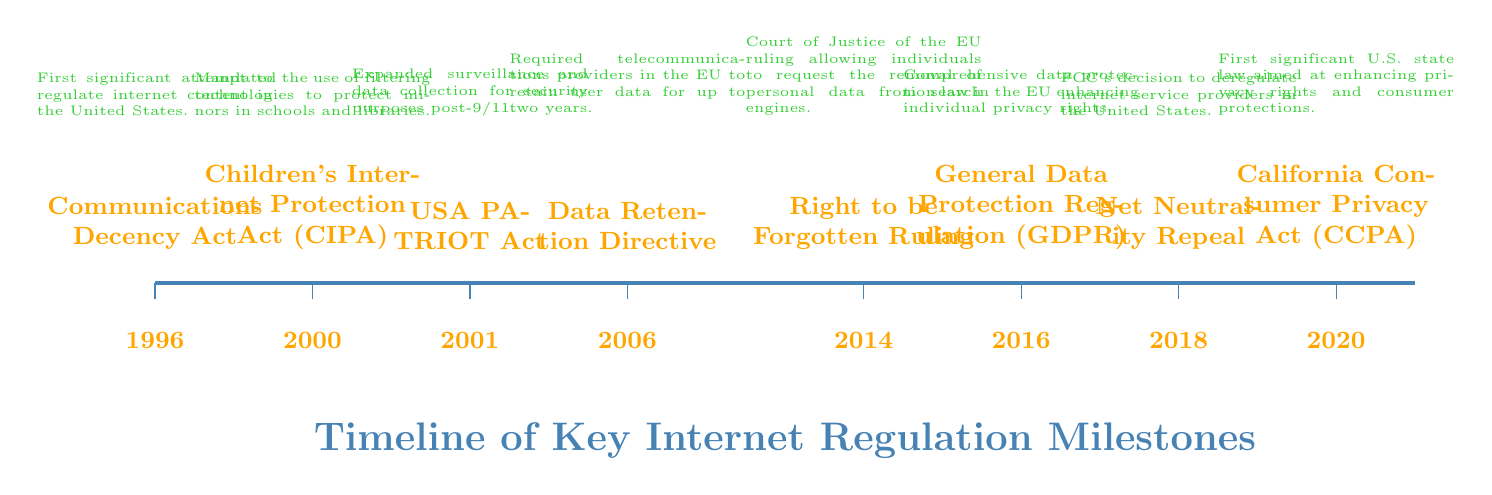What year was the Communications Decency Act enacted? The diagram indicates that the Communications Decency Act was enacted in the year 1996, as stated directly above the related event marker.
Answer: 1996 How many key milestones are represented in the timeline? By counting the events listed in the diagram from 1996 to 2020, there are a total of eight key milestones shown along the timeline.
Answer: 8 What event occurred in 2016? The event corresponding to 2016 in the timeline is labeled "Net Neutrality Repeal," which is clearly indicated above the year marker in the diagram.
Answer: Net Neutrality Repeal What was the main purpose of the General Data Protection Regulation (GDPR)? The description associated with the GDPR in the diagram states that it is a comprehensive data protection law aiming to enhance individual privacy rights in the EU, indicating its focus on data protection.
Answer: Enhance individual privacy rights Which act mandated the use of filtering technologies to protect minors? According to the timeline, the Children's Internet Protection Act, enacted in 2000, is specifically mentioned as having mandated filtering technologies for the protection of minors in schools and libraries.
Answer: Children's Internet Protection Act (CIPA) How did the USA PATRIOT Act change internet regulations? The diagram notes that the USA PATRIOT Act expanded surveillance and data collection for security purposes after 9/11, indicating a broader authority for data monitoring in internet regulations.
Answer: Expanded surveillance and data collection What is the significance of the Right to be Forgotten ruling? This ruling, as mentioned in the diagram, allows individuals to request the removal of personal data from search engines, signifying a significant change in data rights and privacy in the EU.
Answer: Removal of personal data Which event was the first significant attempt to regulate internet content in the US? The timeline indicates that the first significant attempt to regulate internet content in the US was the Communications Decency Act, enacted in 1996.
Answer: Communications Decency Act 